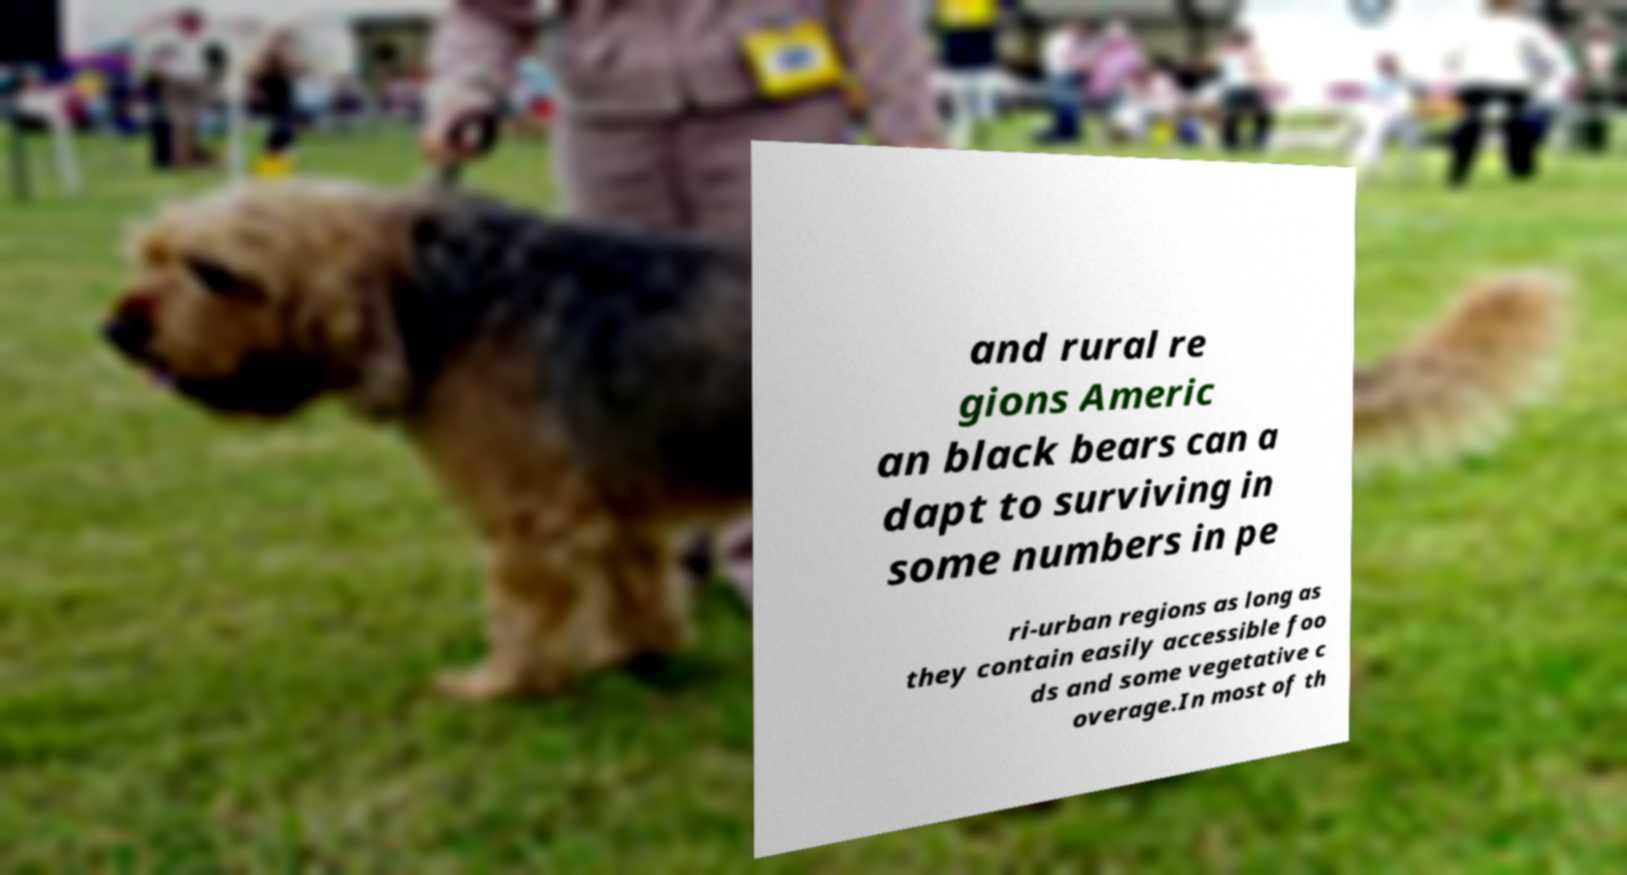I need the written content from this picture converted into text. Can you do that? and rural re gions Americ an black bears can a dapt to surviving in some numbers in pe ri-urban regions as long as they contain easily accessible foo ds and some vegetative c overage.In most of th 